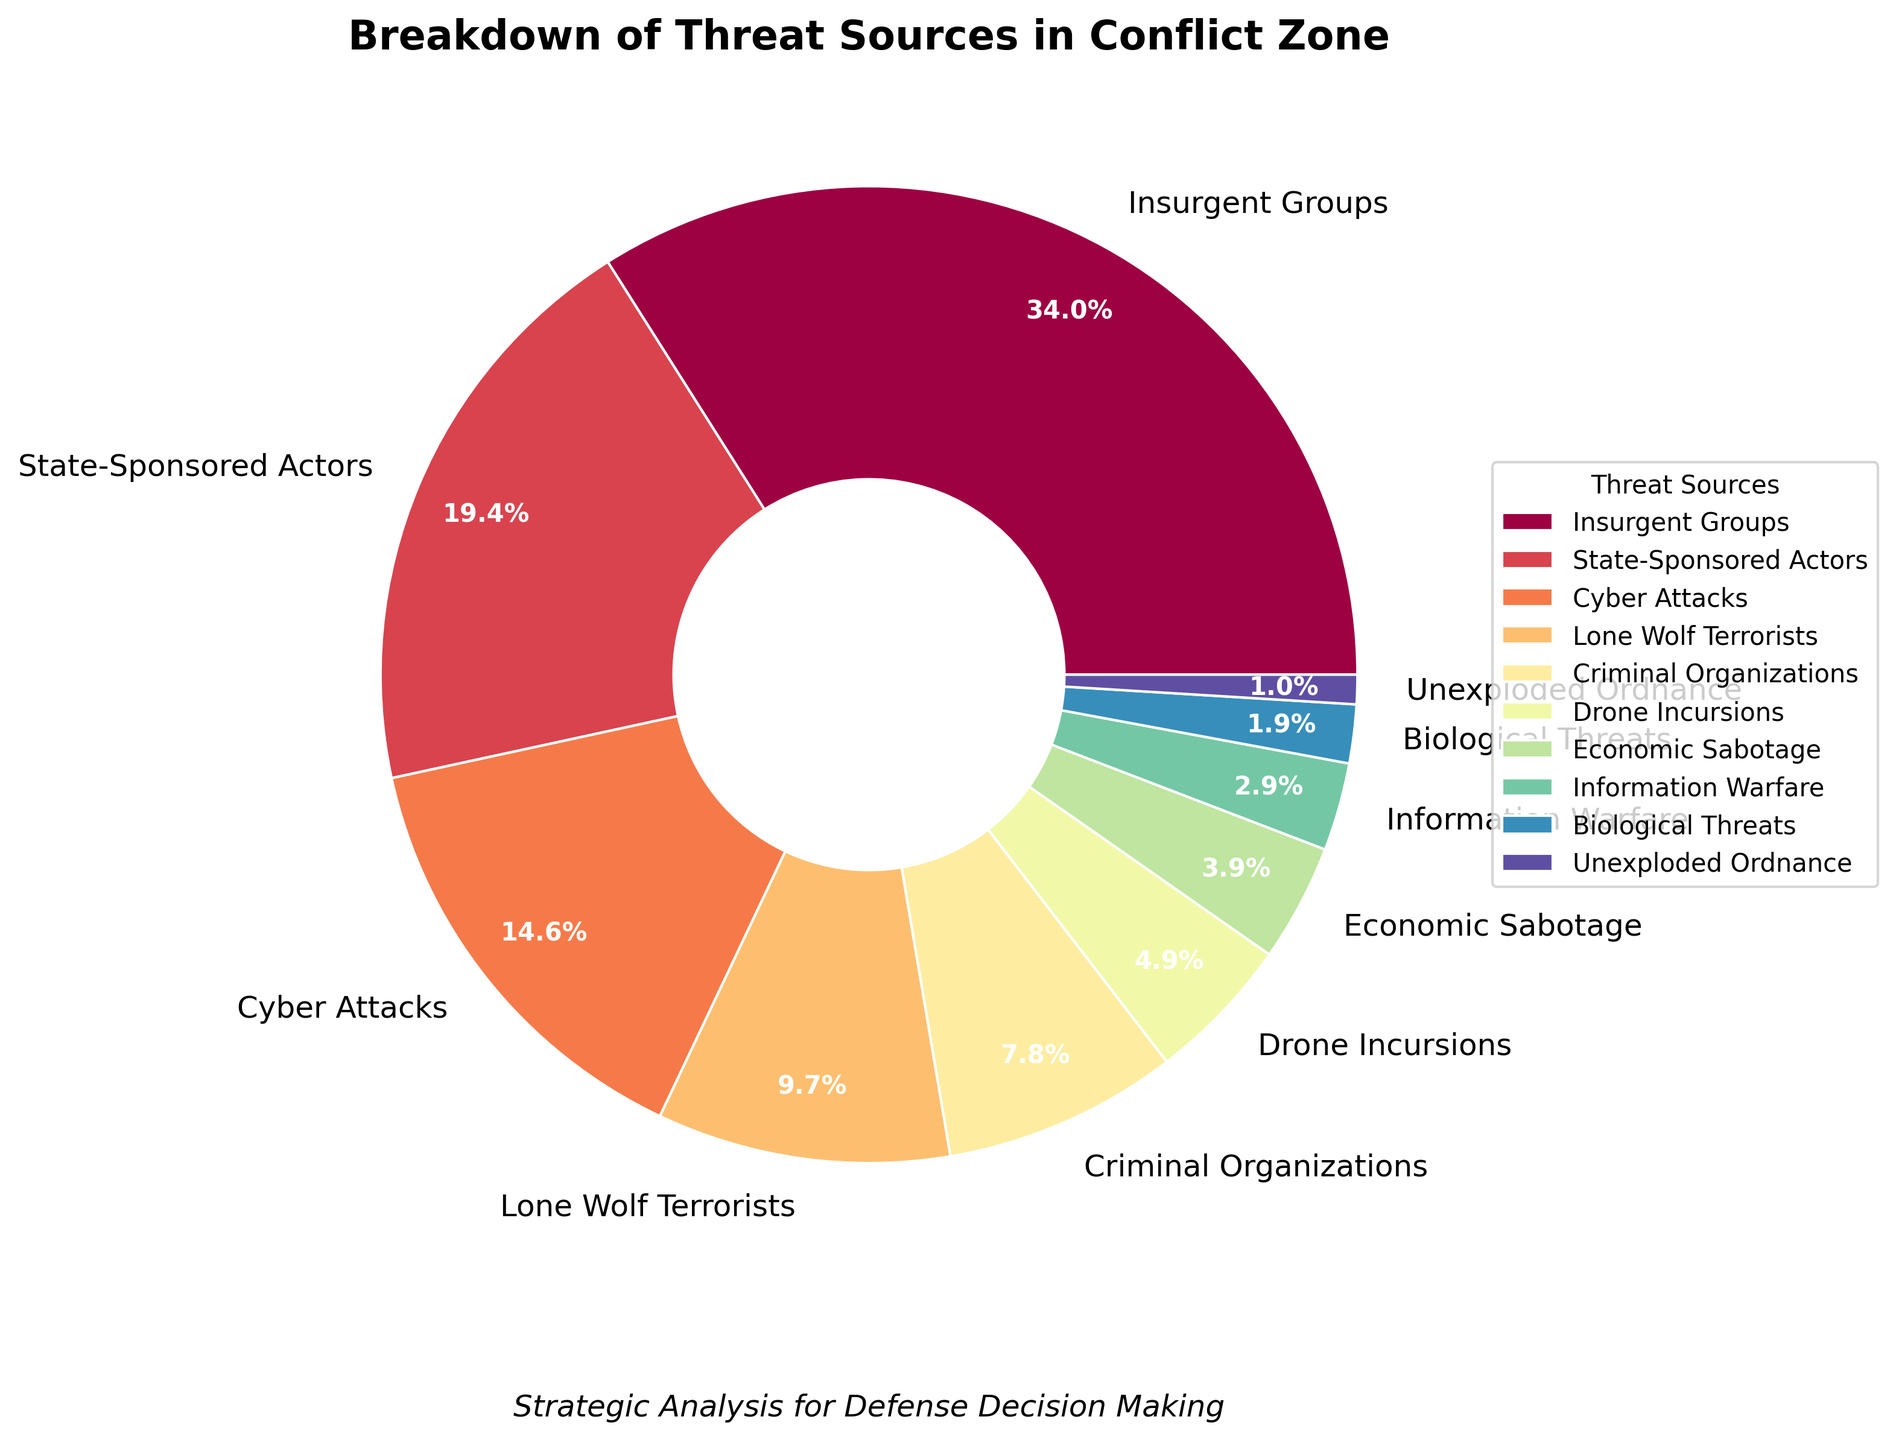How many threat sources contribute less than 5% each? By inspecting the pie chart, we see the percentages for each threat source. The ones contributing less than 5% are Economic Sabotage (4%), Information Warfare (3%), Biological Threats (2%), and Unexploded Ordnance (1%). Counting these, we get 4 threat sources.
Answer: 4 Which threat source has the highest percentage, and what is that percentage? The pie chart shows that Insurgent Groups have the largest wedge. The label indicates this group's percentage as 35%. Hence, Insurgent Groups have the highest percentage at 35%.
Answer: Insurgent Groups, 35% What is the combined percentage of State-Sponsored Actors and Cyber Attacks? From the chart, the percentage for State-Sponsored Actors is 20%, and for Cyber Attacks, it is 15%. Adding these gives 20% + 15% = 35%.
Answer: 35% Which threat source is represented by the smallest wedge, and what is the corresponding percentage? Observing the smallest wedge in the pie chart, Unexploded Ordnance is the smallest, with a percentage label of 1%.
Answer: Unexploded Ordnance, 1% How does the percentage of Criminal Organizations compare to that of Lone Wolf Terrorists? From the pie chart, Criminal Organizations account for 8%, while Lone Wolf Terrorists are at 10%. Comparing these, Criminal Organizations have a smaller percentage than Lone Wolf Terrorists.
Answer: smaller What is the difference in percentage between Drone Incursions and Economic Sabotage? The chart lists Drone Incursions as 5% and Economic Sabotage as 4%. The difference is 5% - 4% = 1%.
Answer: 1% Does the combined percentage of Economic Sabotage and Information Warfare exceed that of Cyber Attacks? Economic Sabotage is 4%, and Information Warfare is 3%. Their combined percentage is 4% + 3% = 7%. Cyber Attacks are at 15%. Thus, 7% does not exceed 15%.
Answer: No What's the total percentage for all the threat sources related to traditional warfare (Insurgent Groups, State-Sponsored Actors, Drone Incursions)? Referring to the pie chart, Insurgent Groups have 35%, State-Sponsored Actors 20%, and Drone Incursions 5%. Adding these, we get 35% + 20% + 5% = 60%.
Answer: 60% Which color represents Biological Threats and what is its percentage? Examining the pie chart, Biological Threats are labeled with a certain color and marked as 2%.
Answer: 2% What percentage of threat sources is not attributed to Cyber Attacks? Cyber Attacks are at 15%. To find the percentage not attributed to them, subtract 15% from 100%. This calculation yields 100% - 15% = 85%.
Answer: 85% 